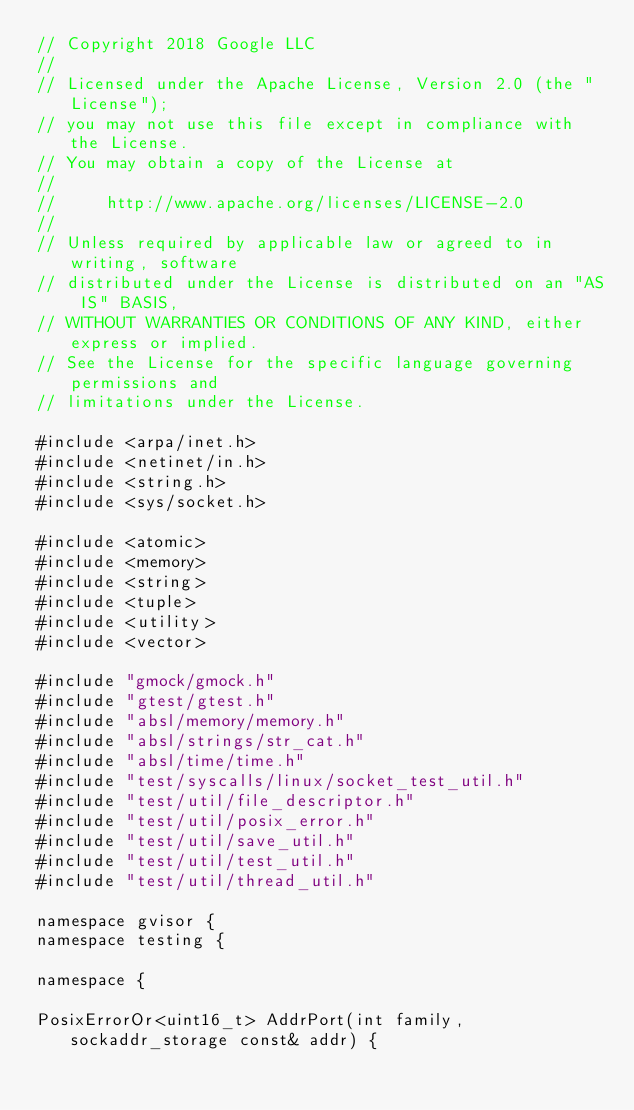Convert code to text. <code><loc_0><loc_0><loc_500><loc_500><_C++_>// Copyright 2018 Google LLC
//
// Licensed under the Apache License, Version 2.0 (the "License");
// you may not use this file except in compliance with the License.
// You may obtain a copy of the License at
//
//     http://www.apache.org/licenses/LICENSE-2.0
//
// Unless required by applicable law or agreed to in writing, software
// distributed under the License is distributed on an "AS IS" BASIS,
// WITHOUT WARRANTIES OR CONDITIONS OF ANY KIND, either express or implied.
// See the License for the specific language governing permissions and
// limitations under the License.

#include <arpa/inet.h>
#include <netinet/in.h>
#include <string.h>
#include <sys/socket.h>

#include <atomic>
#include <memory>
#include <string>
#include <tuple>
#include <utility>
#include <vector>

#include "gmock/gmock.h"
#include "gtest/gtest.h"
#include "absl/memory/memory.h"
#include "absl/strings/str_cat.h"
#include "absl/time/time.h"
#include "test/syscalls/linux/socket_test_util.h"
#include "test/util/file_descriptor.h"
#include "test/util/posix_error.h"
#include "test/util/save_util.h"
#include "test/util/test_util.h"
#include "test/util/thread_util.h"

namespace gvisor {
namespace testing {

namespace {

PosixErrorOr<uint16_t> AddrPort(int family, sockaddr_storage const& addr) {</code> 